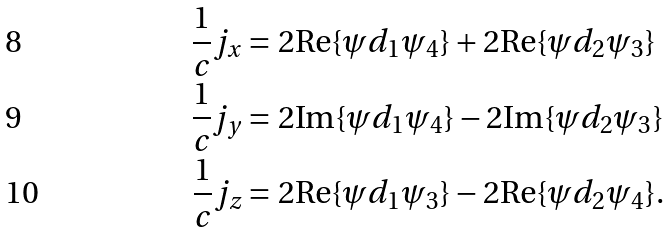<formula> <loc_0><loc_0><loc_500><loc_500>\frac { 1 } { c } j _ { x } & = 2 \text {Re} \{ \psi d _ { 1 } \psi _ { 4 } \} + 2 \text {Re} \{ \psi d _ { 2 } \psi _ { 3 } \} \\ \frac { 1 } { c } j _ { y } & = 2 \text {Im} \{ \psi d _ { 1 } \psi _ { 4 } \} - 2 \text {Im} \{ \psi d _ { 2 } \psi _ { 3 } \} \\ \frac { 1 } { c } j _ { z } & = 2 \text {Re} \{ \psi d _ { 1 } \psi _ { 3 } \} - 2 \text {Re} \{ \psi d _ { 2 } \psi _ { 4 } \} .</formula> 